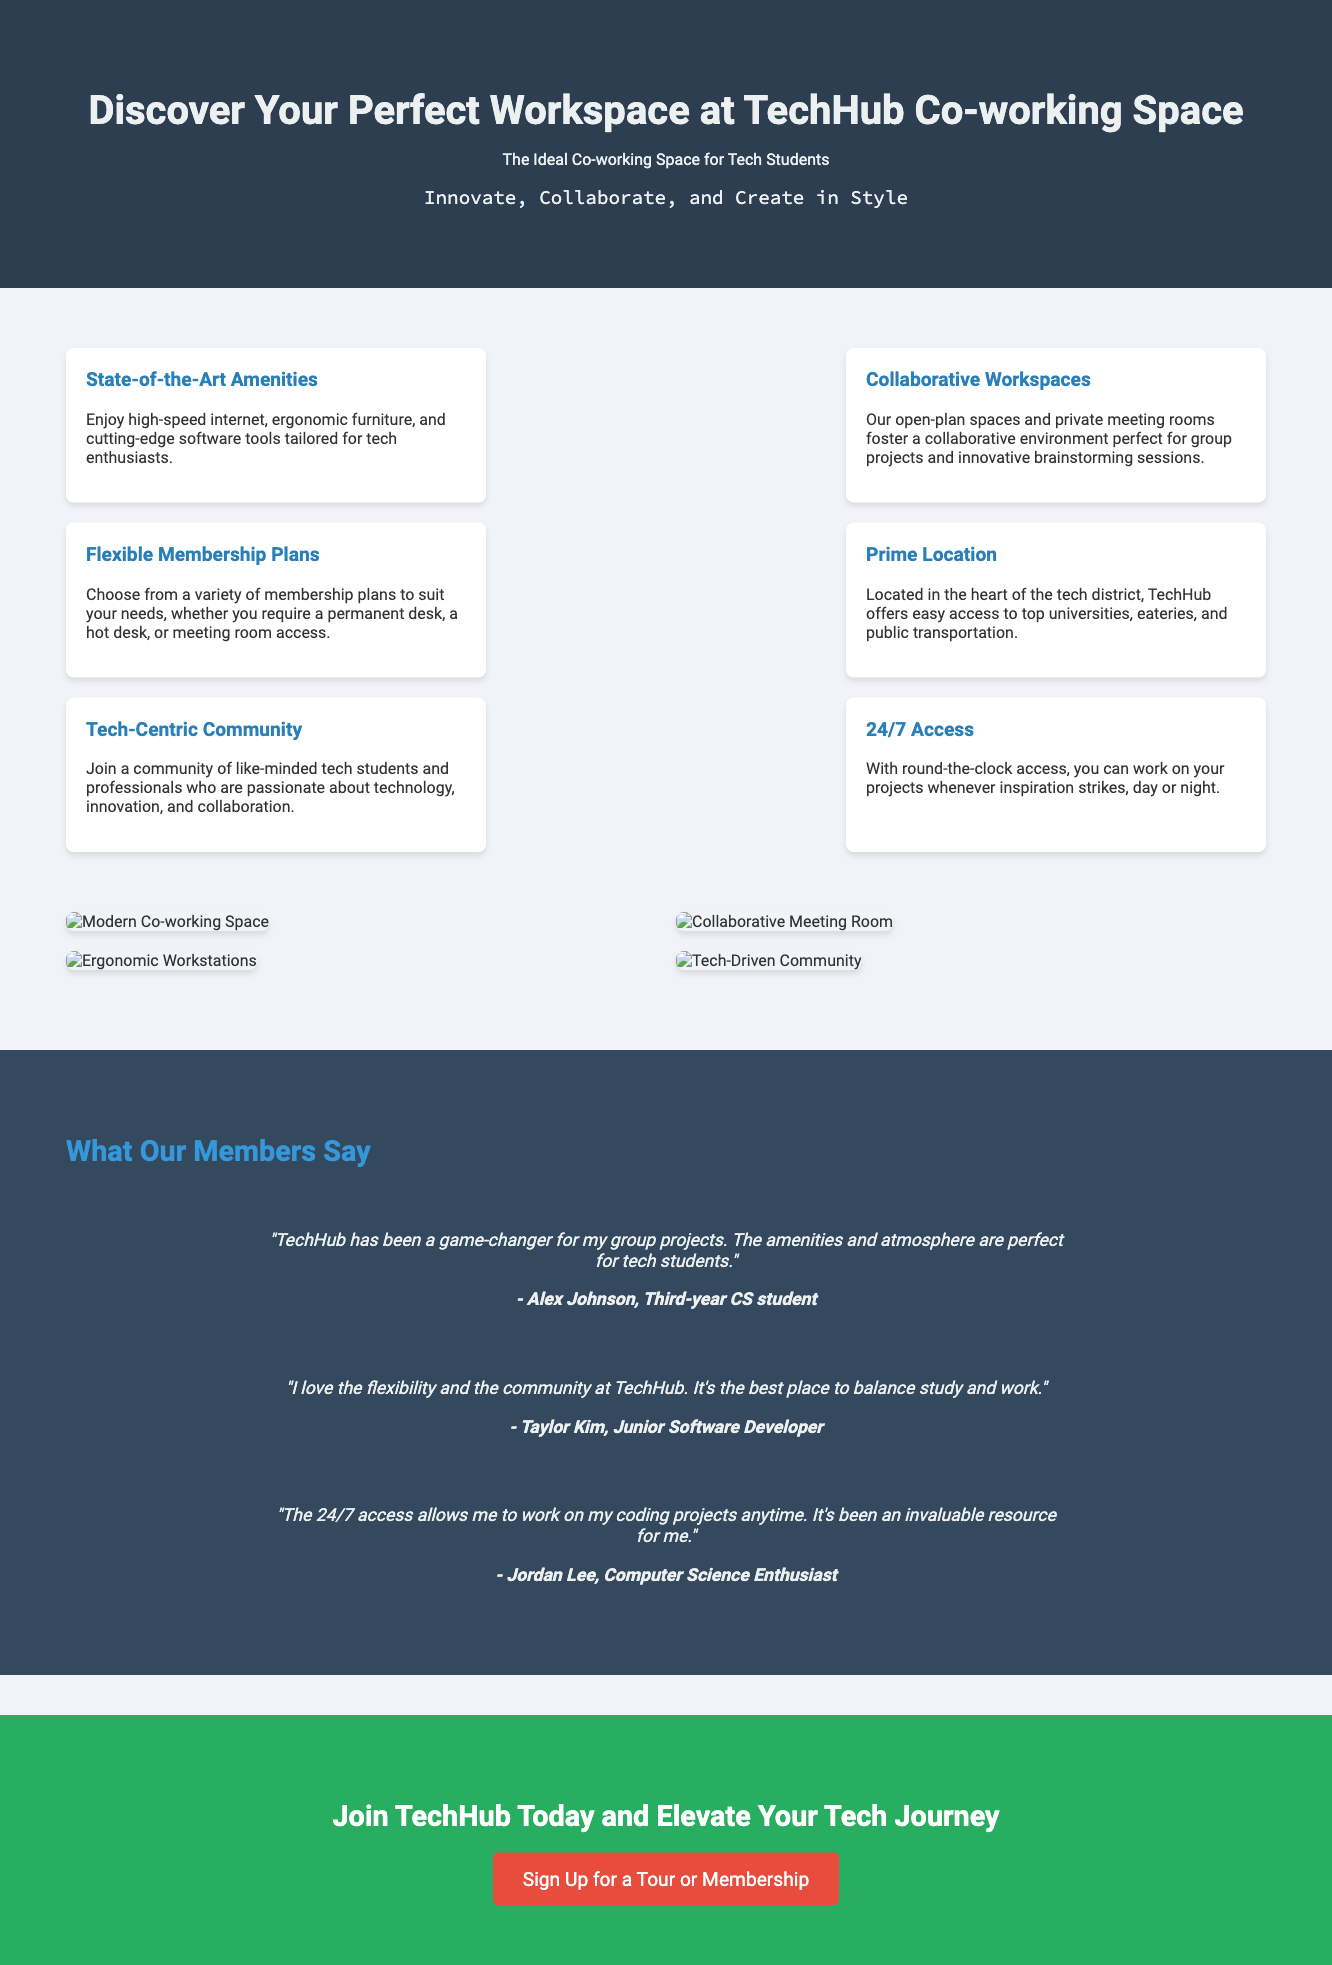What is the name of the co-working space? The co-working space is named "TechHub Co-working Space."
Answer: TechHub Co-working Space What types of workspaces are mentioned? The advertisement describes open-plan spaces and private meeting rooms.
Answer: Open-plan spaces and private meeting rooms How many features are listed in the advertisement? There are six features listed in the section of features.
Answer: Six What is the tagline of the advertisement? The tagline is "Innovate, Collaborate, and Create in Style."
Answer: Innovate, Collaborate, and Create in Style Who is a member that provided a testimonial? The advertisement provides a testimonial from Alex Johnson.
Answer: Alex Johnson What is the primary target audience for TechHub? The advertisement indicates that the target audience is tech students.
Answer: Tech students What does the 'cta' section encourage potential members to do? The 'cta' section encourages potential members to sign up for a tour or membership.
Answer: Sign up for a tour or membership What benefit does the 24/7 access provide? The 24/7 access allows members to work on their projects whenever they want.
Answer: Work on projects anytime How is the community described in the advertisement? The community is described as a tech-centric community of like-minded individuals.
Answer: Tech-centric community 